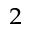<formula> <loc_0><loc_0><loc_500><loc_500>_ { 2 }</formula> 